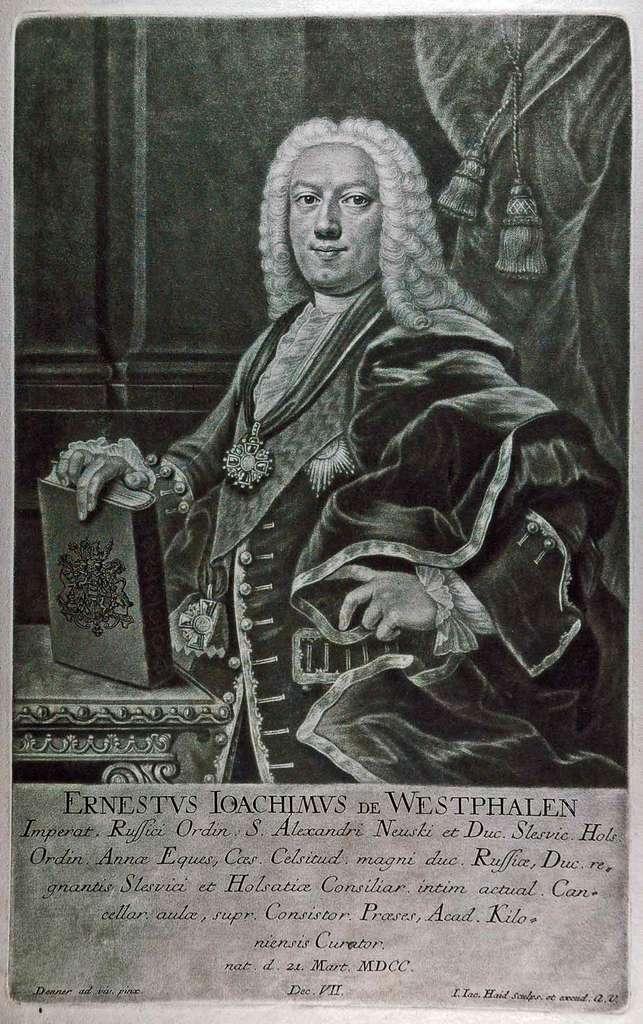Can you describe this image briefly? In this image we can see a picture of a man holding a book. We can also see some written text down to the image. 